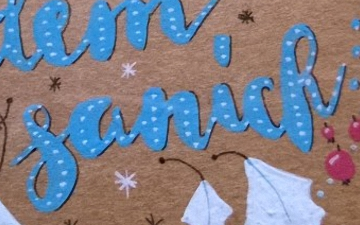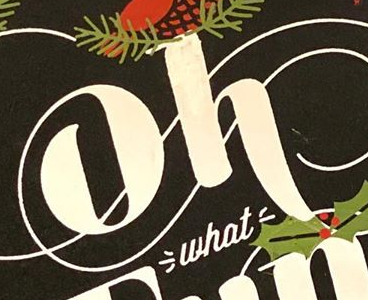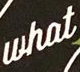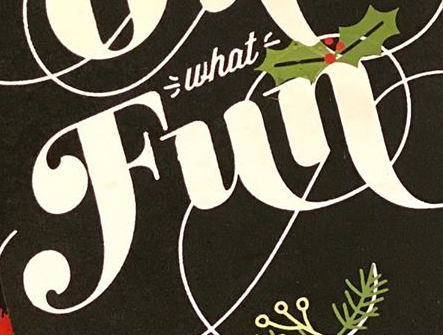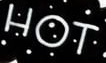Read the text from these images in sequence, separated by a semicolon. sanick; oh; what; Fun; HOT 